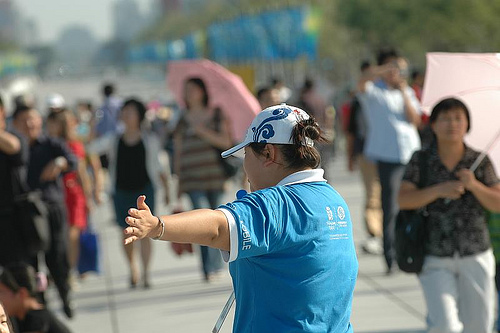<image>
Is the people in front of the man? No. The people is not in front of the man. The spatial positioning shows a different relationship between these objects. Is the pink umbrella above the lady? Yes. The pink umbrella is positioned above the lady in the vertical space, higher up in the scene. 